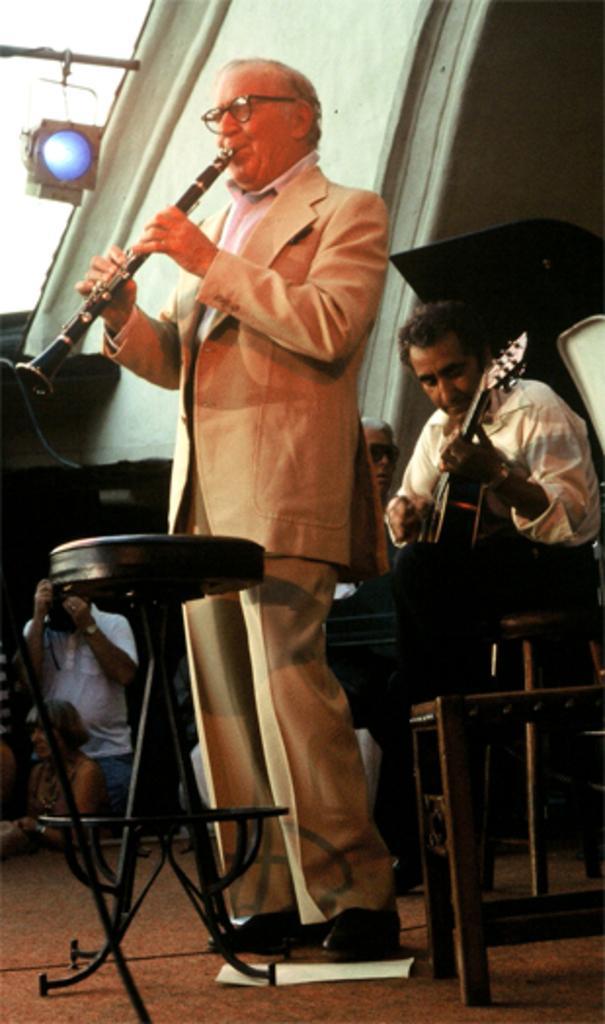Could you give a brief overview of what you see in this image? In this image there is a person playing clarinet, behind the person there is another person playing guitar, in the background of the image there is a person clicking the image, in front of the image there is a stool. 